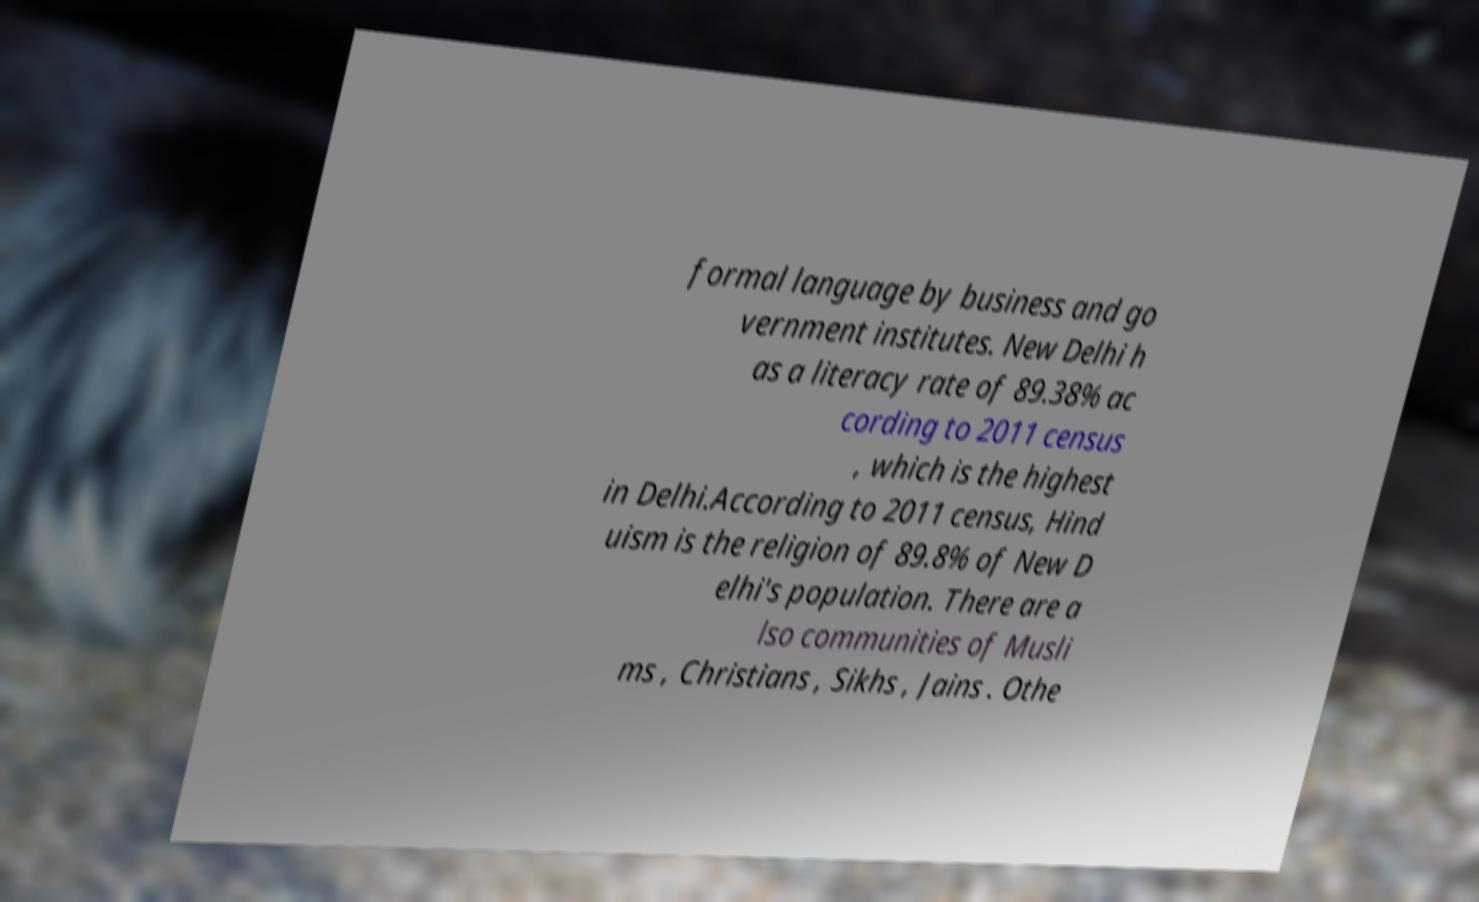What messages or text are displayed in this image? I need them in a readable, typed format. formal language by business and go vernment institutes. New Delhi h as a literacy rate of 89.38% ac cording to 2011 census , which is the highest in Delhi.According to 2011 census, Hind uism is the religion of 89.8% of New D elhi's population. There are a lso communities of Musli ms , Christians , Sikhs , Jains . Othe 